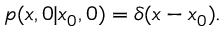Convert formula to latex. <formula><loc_0><loc_0><loc_500><loc_500>p ( x , 0 | x _ { 0 } , 0 ) = \delta ( x - x _ { 0 } ) .</formula> 